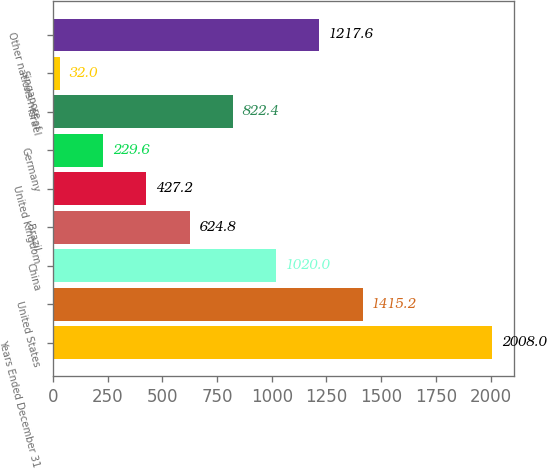Convert chart to OTSL. <chart><loc_0><loc_0><loc_500><loc_500><bar_chart><fcel>Years Ended December 31<fcel>United States<fcel>China<fcel>Brazil<fcel>United Kingdom<fcel>Germany<fcel>Israel<fcel>Singapore<fcel>Other nations net of<nl><fcel>2008<fcel>1415.2<fcel>1020<fcel>624.8<fcel>427.2<fcel>229.6<fcel>822.4<fcel>32<fcel>1217.6<nl></chart> 